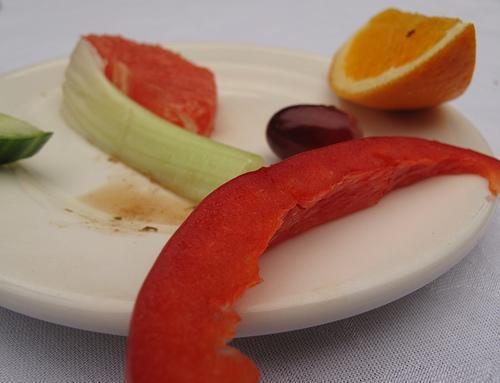How many items on the plate?
Give a very brief answer. 6. How many fruits?
Give a very brief answer. 3. How many vegetables?
Give a very brief answer. 3. 